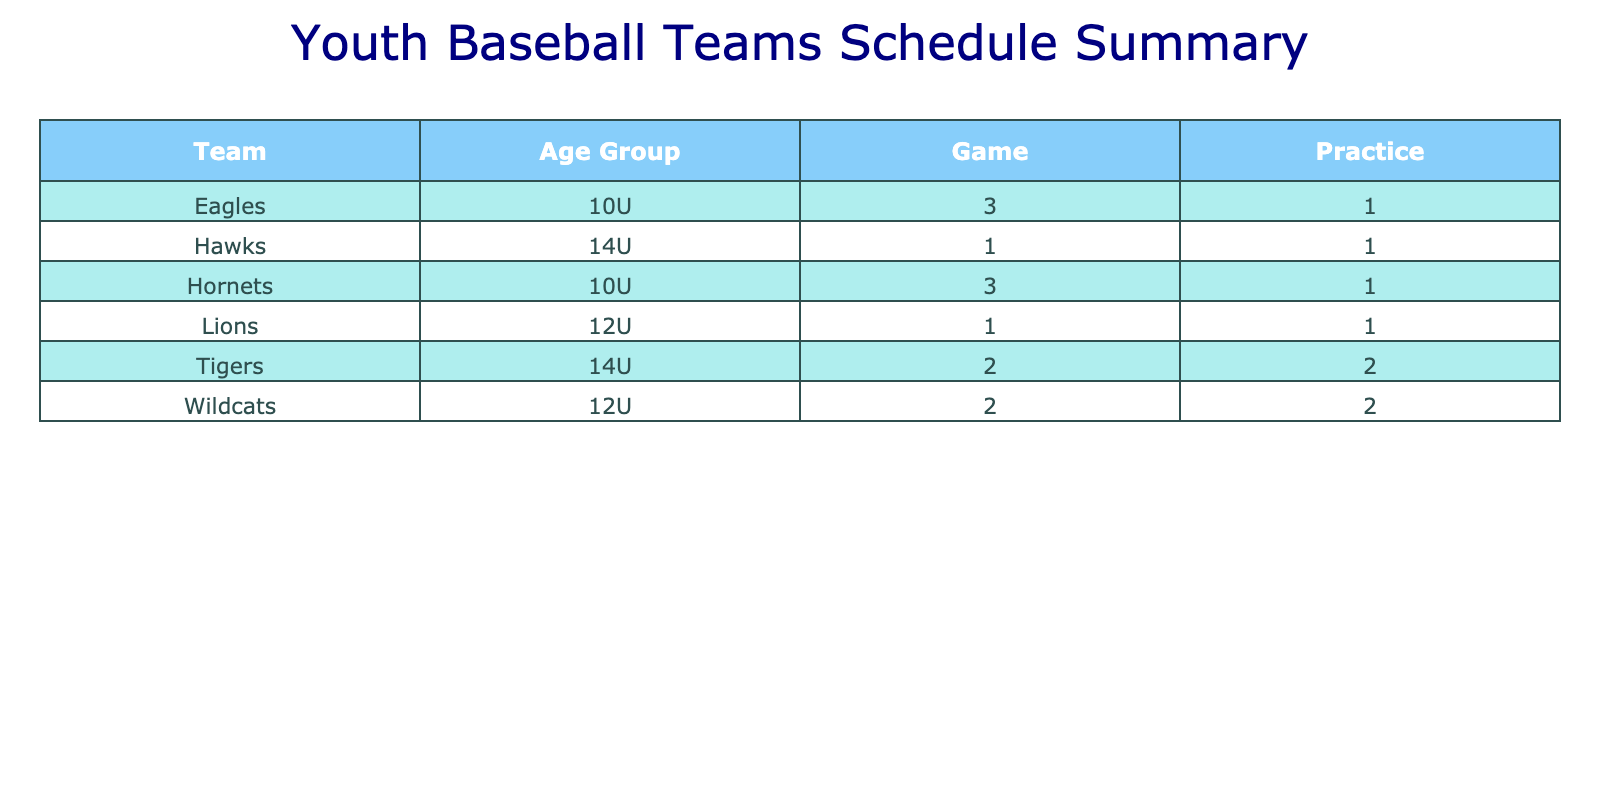What is the total number of games played by the Wildcats? In the table, we look for all entries under the "Game" category for the Wildcats. There are three entries: one on May 5 against the Tigers, one on May 11 against the Eagles, and one on May 17 practicing against the Hornets. Therefore, the total number of games played is 3.
Answer: 3 How many practices did the Eagles conduct? We search for entries under the "Practice" category for the Eagles. There are two practices scheduled: on May 12 and an additional one on May 18. Therefore, the total count of practices conducted by the Eagles is 2.
Answer: 2 Did the Hornets have a game against the Lions? We look at the entries for the Hornets to see if they played a game with the Lions. There is an entry on May 20 for the Hornets with the Lions, which confirms that this game occurred.
Answer: Yes Which team played the most games? We analyze the table for the total count of games played by each team. The Wildcats played three games, the Eagles played two games, the Tigers played two games, the Hornets played three games, and the Lions did not play any games. The Wildcats and Hornets both have the highest count of games played at three.
Answer: Wildcats and Hornets How many games were played on May 12? We count the entries in the table for the date of May 12. There is one game listed, which is the Eagles playing against the Lions. Thus, the total number of games played on this date is 1.
Answer: 1 How many total practices were conducted across all teams? We sum up the number of practices for each team listed in the table. The Wildcats had three practices, the Eagles had two practices, the Tigers had two practices, and the Hornets had one practice. Adding these together gives us a total of 8 practices across all teams.
Answer: 8 What age group participated in the most games? We look at the game entries by age group and count the games. 10U teams played four games, 12U teams played three games, and 14U teams played three games. Thus, the 10U age group had the highest participation in games.
Answer: 10U How many games did the Tigers lose? To find this, we look for the games in which the Tigers participated. They played against the Wildcats and Hawks, losing both matches (assuming that the opponent winning isn't explicitly stated). Consequently, the Tigers lost two games.
Answer: 2 